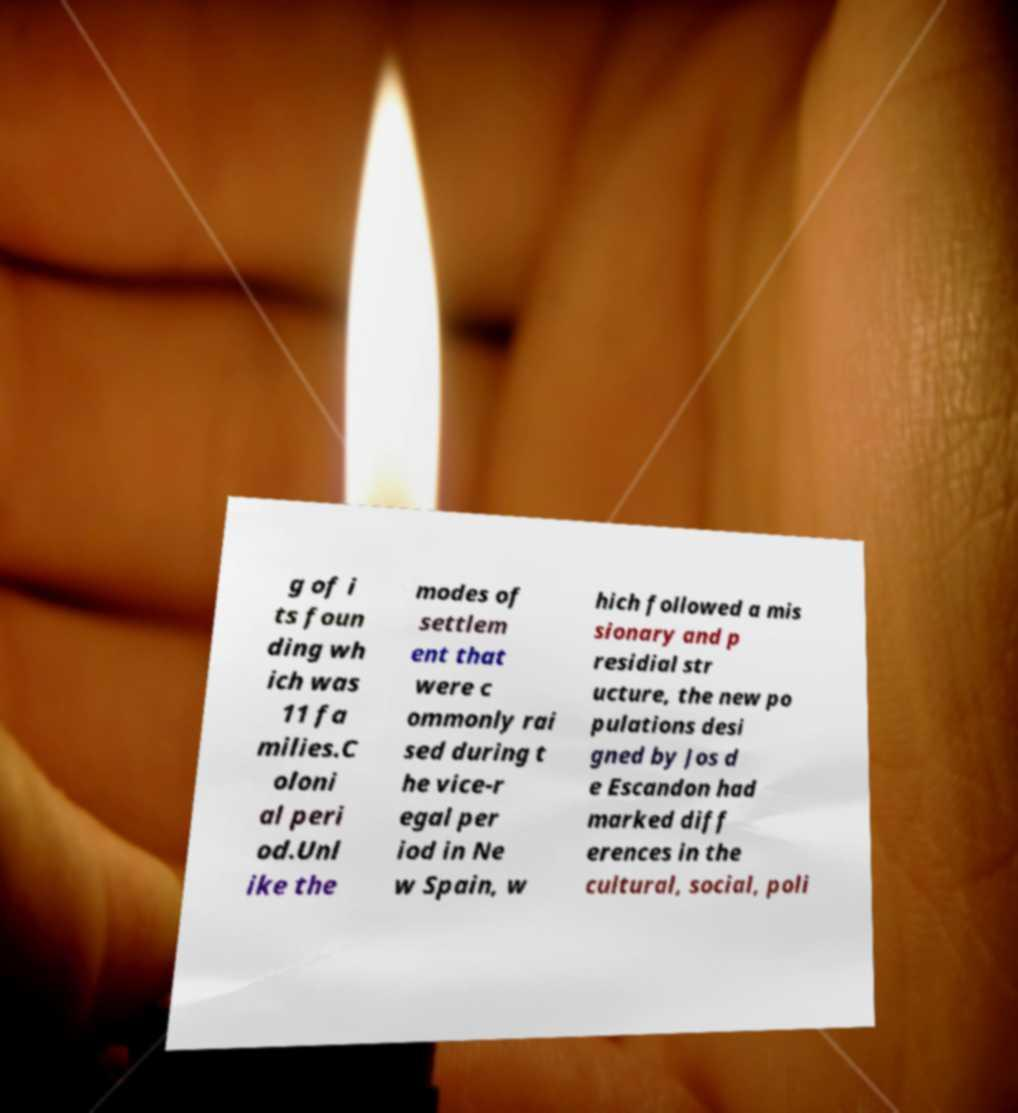I need the written content from this picture converted into text. Can you do that? g of i ts foun ding wh ich was 11 fa milies.C oloni al peri od.Unl ike the modes of settlem ent that were c ommonly rai sed during t he vice-r egal per iod in Ne w Spain, w hich followed a mis sionary and p residial str ucture, the new po pulations desi gned by Jos d e Escandon had marked diff erences in the cultural, social, poli 